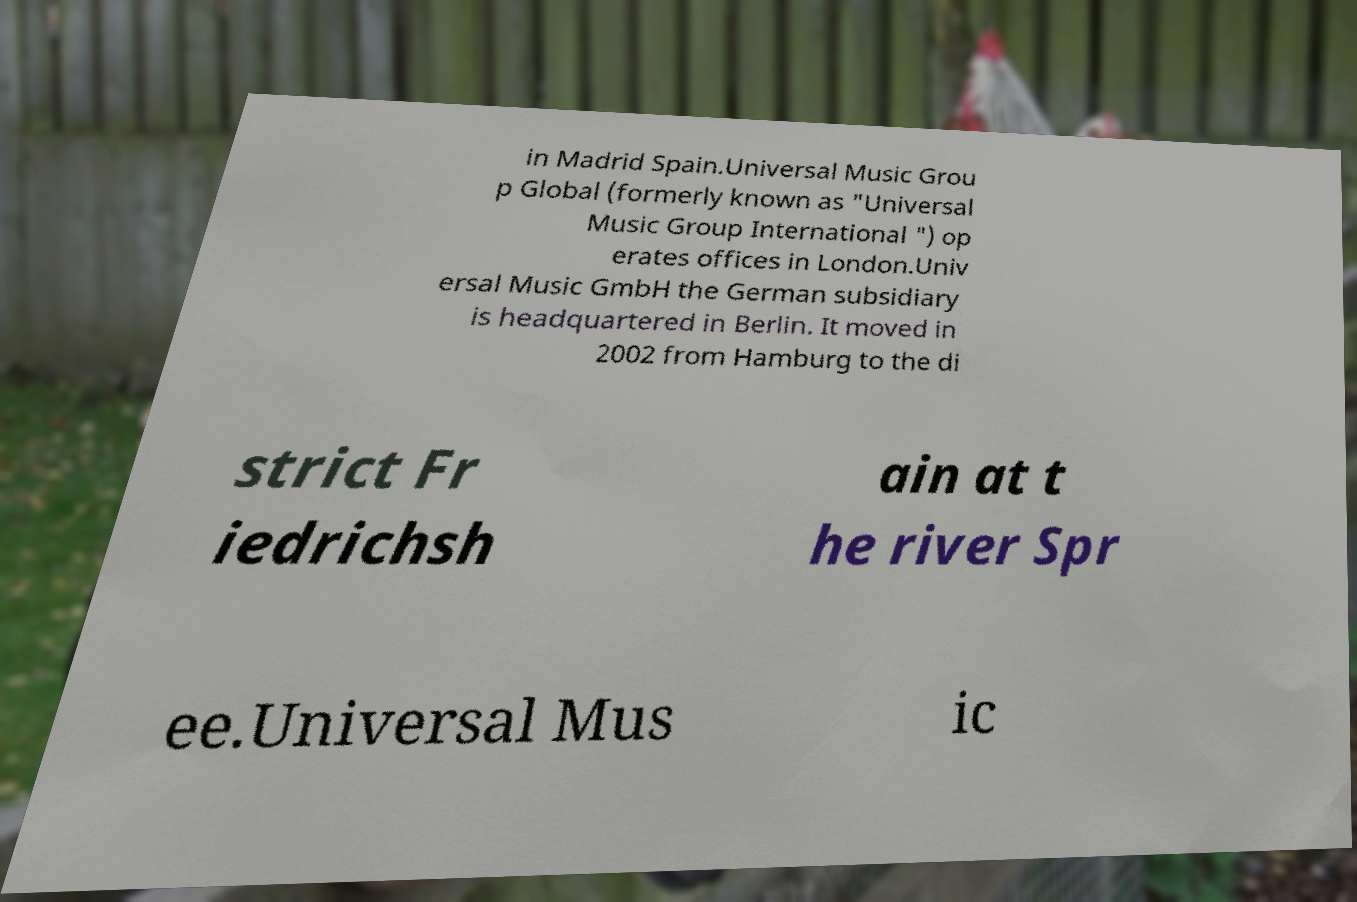Please read and relay the text visible in this image. What does it say? in Madrid Spain.Universal Music Grou p Global (formerly known as "Universal Music Group International ") op erates offices in London.Univ ersal Music GmbH the German subsidiary is headquartered in Berlin. It moved in 2002 from Hamburg to the di strict Fr iedrichsh ain at t he river Spr ee.Universal Mus ic 